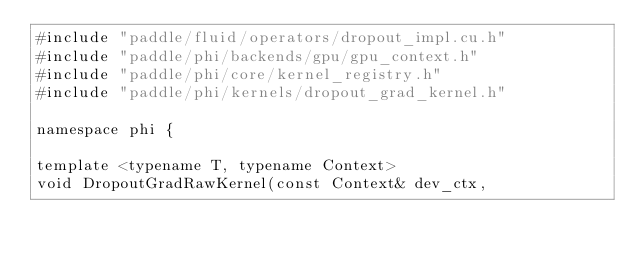Convert code to text. <code><loc_0><loc_0><loc_500><loc_500><_Cuda_>#include "paddle/fluid/operators/dropout_impl.cu.h"
#include "paddle/phi/backends/gpu/gpu_context.h"
#include "paddle/phi/core/kernel_registry.h"
#include "paddle/phi/kernels/dropout_grad_kernel.h"

namespace phi {

template <typename T, typename Context>
void DropoutGradRawKernel(const Context& dev_ctx,</code> 